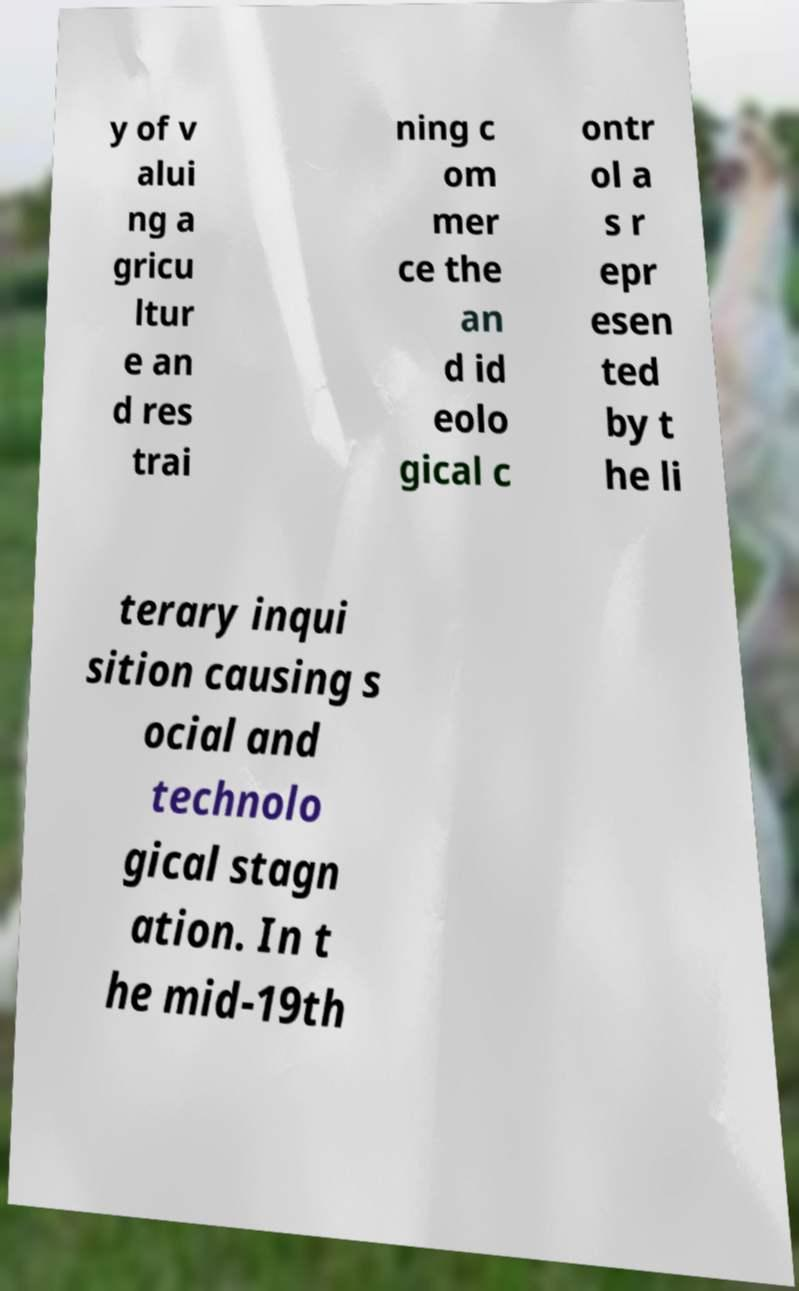There's text embedded in this image that I need extracted. Can you transcribe it verbatim? y of v alui ng a gricu ltur e an d res trai ning c om mer ce the an d id eolo gical c ontr ol a s r epr esen ted by t he li terary inqui sition causing s ocial and technolo gical stagn ation. In t he mid-19th 